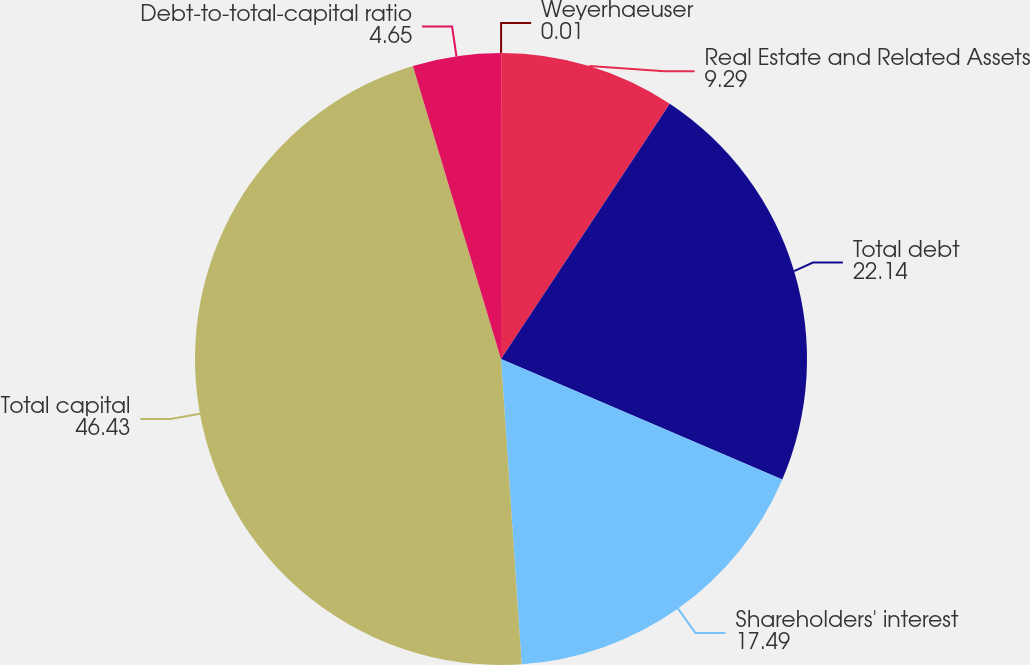Convert chart. <chart><loc_0><loc_0><loc_500><loc_500><pie_chart><fcel>Weyerhaeuser<fcel>Real Estate and Related Assets<fcel>Total debt<fcel>Shareholders' interest<fcel>Total capital<fcel>Debt-to-total-capital ratio<nl><fcel>0.01%<fcel>9.29%<fcel>22.14%<fcel>17.49%<fcel>46.43%<fcel>4.65%<nl></chart> 